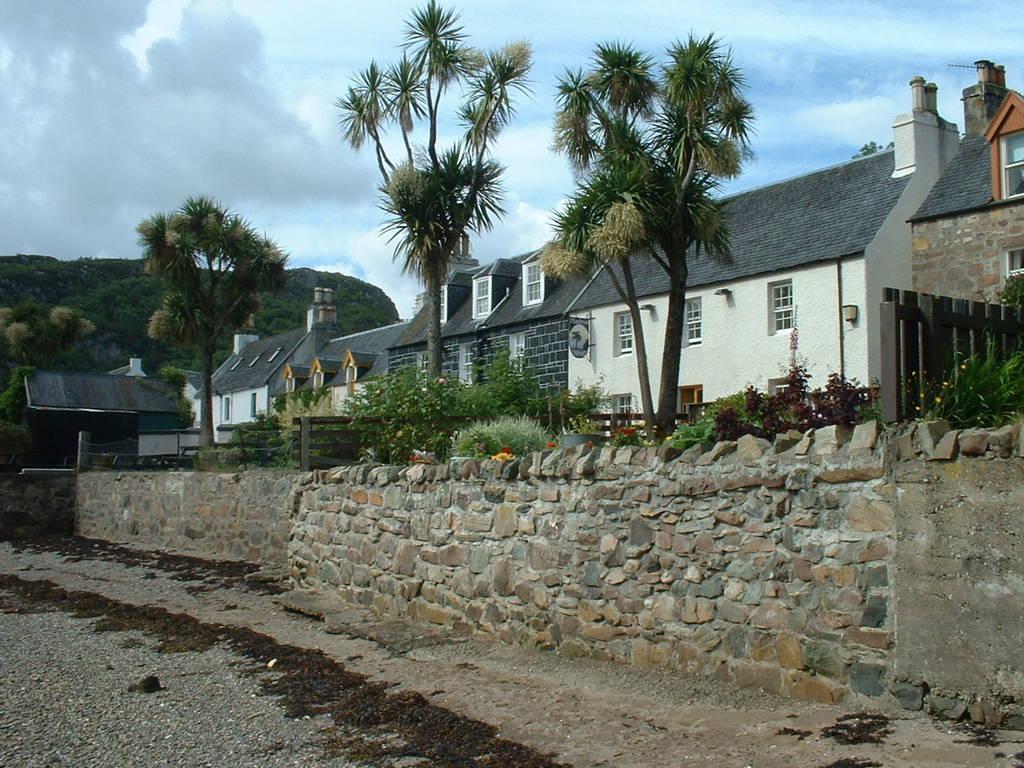Please provide a concise description of this image. At the bottom of the picture, we see a picket fence. Beside that, we see a wall which is made up of cobblestones. Beside that, we see plants and picket fence. On the right side, we see trees and buildings in white color with grey color roofs. There are trees in the background. At the top of the picture, we see the sky. 